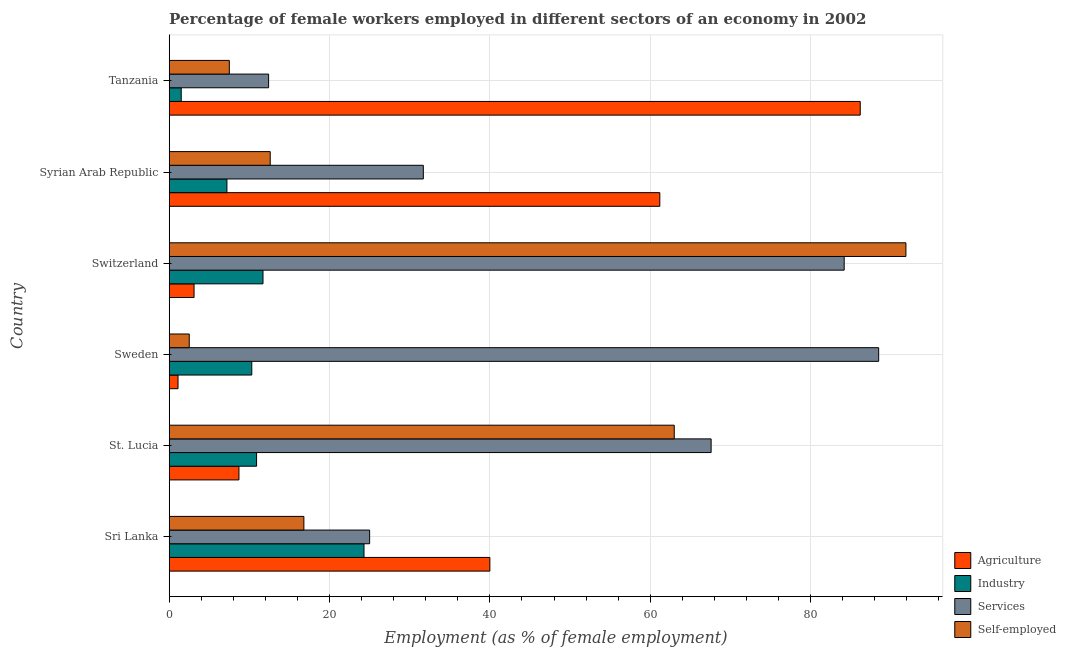How many groups of bars are there?
Ensure brevity in your answer.  6. Are the number of bars on each tick of the Y-axis equal?
Provide a short and direct response. Yes. What is the label of the 5th group of bars from the top?
Your answer should be very brief. St. Lucia. What is the percentage of female workers in agriculture in Tanzania?
Your answer should be compact. 86.2. Across all countries, what is the maximum percentage of female workers in industry?
Offer a very short reply. 24.3. In which country was the percentage of female workers in industry maximum?
Provide a short and direct response. Sri Lanka. In which country was the percentage of female workers in industry minimum?
Your response must be concise. Tanzania. What is the total percentage of female workers in agriculture in the graph?
Your answer should be compact. 200.3. What is the difference between the percentage of female workers in agriculture in Sri Lanka and that in Tanzania?
Your answer should be compact. -46.2. What is the difference between the percentage of female workers in services in Sri Lanka and the percentage of female workers in industry in Syrian Arab Republic?
Offer a very short reply. 17.8. What is the average percentage of female workers in agriculture per country?
Keep it short and to the point. 33.38. What is the difference between the percentage of female workers in services and percentage of female workers in agriculture in Switzerland?
Ensure brevity in your answer.  81.1. What is the ratio of the percentage of female workers in industry in Sri Lanka to that in Sweden?
Your response must be concise. 2.36. What is the difference between the highest and the lowest percentage of female workers in agriculture?
Your response must be concise. 85.1. Is the sum of the percentage of female workers in agriculture in Switzerland and Syrian Arab Republic greater than the maximum percentage of female workers in industry across all countries?
Your answer should be compact. Yes. What does the 1st bar from the top in St. Lucia represents?
Your answer should be very brief. Self-employed. What does the 2nd bar from the bottom in Sweden represents?
Ensure brevity in your answer.  Industry. How many countries are there in the graph?
Provide a short and direct response. 6. What is the difference between two consecutive major ticks on the X-axis?
Offer a terse response. 20. Does the graph contain any zero values?
Provide a succinct answer. No. Does the graph contain grids?
Ensure brevity in your answer.  Yes. Where does the legend appear in the graph?
Ensure brevity in your answer.  Bottom right. How many legend labels are there?
Your answer should be very brief. 4. How are the legend labels stacked?
Ensure brevity in your answer.  Vertical. What is the title of the graph?
Ensure brevity in your answer.  Percentage of female workers employed in different sectors of an economy in 2002. What is the label or title of the X-axis?
Offer a very short reply. Employment (as % of female employment). What is the label or title of the Y-axis?
Make the answer very short. Country. What is the Employment (as % of female employment) of Agriculture in Sri Lanka?
Make the answer very short. 40. What is the Employment (as % of female employment) of Industry in Sri Lanka?
Your response must be concise. 24.3. What is the Employment (as % of female employment) of Services in Sri Lanka?
Your answer should be very brief. 25. What is the Employment (as % of female employment) in Self-employed in Sri Lanka?
Offer a terse response. 16.8. What is the Employment (as % of female employment) in Agriculture in St. Lucia?
Ensure brevity in your answer.  8.7. What is the Employment (as % of female employment) of Industry in St. Lucia?
Provide a short and direct response. 10.9. What is the Employment (as % of female employment) of Services in St. Lucia?
Provide a short and direct response. 67.6. What is the Employment (as % of female employment) in Agriculture in Sweden?
Give a very brief answer. 1.1. What is the Employment (as % of female employment) in Industry in Sweden?
Your answer should be compact. 10.3. What is the Employment (as % of female employment) in Services in Sweden?
Your answer should be compact. 88.5. What is the Employment (as % of female employment) in Agriculture in Switzerland?
Your answer should be compact. 3.1. What is the Employment (as % of female employment) in Industry in Switzerland?
Provide a short and direct response. 11.7. What is the Employment (as % of female employment) in Services in Switzerland?
Offer a very short reply. 84.2. What is the Employment (as % of female employment) in Self-employed in Switzerland?
Your answer should be very brief. 91.9. What is the Employment (as % of female employment) in Agriculture in Syrian Arab Republic?
Your answer should be very brief. 61.2. What is the Employment (as % of female employment) of Industry in Syrian Arab Republic?
Keep it short and to the point. 7.2. What is the Employment (as % of female employment) in Services in Syrian Arab Republic?
Ensure brevity in your answer.  31.7. What is the Employment (as % of female employment) of Self-employed in Syrian Arab Republic?
Keep it short and to the point. 12.6. What is the Employment (as % of female employment) of Agriculture in Tanzania?
Make the answer very short. 86.2. What is the Employment (as % of female employment) of Industry in Tanzania?
Provide a short and direct response. 1.5. What is the Employment (as % of female employment) of Services in Tanzania?
Offer a very short reply. 12.4. What is the Employment (as % of female employment) in Self-employed in Tanzania?
Your answer should be compact. 7.5. Across all countries, what is the maximum Employment (as % of female employment) of Agriculture?
Give a very brief answer. 86.2. Across all countries, what is the maximum Employment (as % of female employment) of Industry?
Your answer should be compact. 24.3. Across all countries, what is the maximum Employment (as % of female employment) of Services?
Your response must be concise. 88.5. Across all countries, what is the maximum Employment (as % of female employment) in Self-employed?
Make the answer very short. 91.9. Across all countries, what is the minimum Employment (as % of female employment) in Agriculture?
Ensure brevity in your answer.  1.1. Across all countries, what is the minimum Employment (as % of female employment) of Industry?
Make the answer very short. 1.5. Across all countries, what is the minimum Employment (as % of female employment) in Services?
Offer a very short reply. 12.4. What is the total Employment (as % of female employment) in Agriculture in the graph?
Provide a short and direct response. 200.3. What is the total Employment (as % of female employment) in Industry in the graph?
Your answer should be very brief. 65.9. What is the total Employment (as % of female employment) in Services in the graph?
Your response must be concise. 309.4. What is the total Employment (as % of female employment) of Self-employed in the graph?
Provide a short and direct response. 194.3. What is the difference between the Employment (as % of female employment) in Agriculture in Sri Lanka and that in St. Lucia?
Provide a succinct answer. 31.3. What is the difference between the Employment (as % of female employment) in Services in Sri Lanka and that in St. Lucia?
Keep it short and to the point. -42.6. What is the difference between the Employment (as % of female employment) in Self-employed in Sri Lanka and that in St. Lucia?
Your response must be concise. -46.2. What is the difference between the Employment (as % of female employment) in Agriculture in Sri Lanka and that in Sweden?
Offer a very short reply. 38.9. What is the difference between the Employment (as % of female employment) in Industry in Sri Lanka and that in Sweden?
Give a very brief answer. 14. What is the difference between the Employment (as % of female employment) of Services in Sri Lanka and that in Sweden?
Your response must be concise. -63.5. What is the difference between the Employment (as % of female employment) in Agriculture in Sri Lanka and that in Switzerland?
Your answer should be very brief. 36.9. What is the difference between the Employment (as % of female employment) in Industry in Sri Lanka and that in Switzerland?
Make the answer very short. 12.6. What is the difference between the Employment (as % of female employment) of Services in Sri Lanka and that in Switzerland?
Make the answer very short. -59.2. What is the difference between the Employment (as % of female employment) in Self-employed in Sri Lanka and that in Switzerland?
Your answer should be very brief. -75.1. What is the difference between the Employment (as % of female employment) in Agriculture in Sri Lanka and that in Syrian Arab Republic?
Your response must be concise. -21.2. What is the difference between the Employment (as % of female employment) of Industry in Sri Lanka and that in Syrian Arab Republic?
Your answer should be compact. 17.1. What is the difference between the Employment (as % of female employment) in Self-employed in Sri Lanka and that in Syrian Arab Republic?
Ensure brevity in your answer.  4.2. What is the difference between the Employment (as % of female employment) of Agriculture in Sri Lanka and that in Tanzania?
Provide a succinct answer. -46.2. What is the difference between the Employment (as % of female employment) of Industry in Sri Lanka and that in Tanzania?
Offer a very short reply. 22.8. What is the difference between the Employment (as % of female employment) of Services in St. Lucia and that in Sweden?
Make the answer very short. -20.9. What is the difference between the Employment (as % of female employment) in Self-employed in St. Lucia and that in Sweden?
Your response must be concise. 60.5. What is the difference between the Employment (as % of female employment) in Agriculture in St. Lucia and that in Switzerland?
Offer a very short reply. 5.6. What is the difference between the Employment (as % of female employment) in Industry in St. Lucia and that in Switzerland?
Your response must be concise. -0.8. What is the difference between the Employment (as % of female employment) of Services in St. Lucia and that in Switzerland?
Make the answer very short. -16.6. What is the difference between the Employment (as % of female employment) in Self-employed in St. Lucia and that in Switzerland?
Offer a terse response. -28.9. What is the difference between the Employment (as % of female employment) in Agriculture in St. Lucia and that in Syrian Arab Republic?
Your answer should be compact. -52.5. What is the difference between the Employment (as % of female employment) of Services in St. Lucia and that in Syrian Arab Republic?
Keep it short and to the point. 35.9. What is the difference between the Employment (as % of female employment) of Self-employed in St. Lucia and that in Syrian Arab Republic?
Ensure brevity in your answer.  50.4. What is the difference between the Employment (as % of female employment) of Agriculture in St. Lucia and that in Tanzania?
Your answer should be compact. -77.5. What is the difference between the Employment (as % of female employment) in Services in St. Lucia and that in Tanzania?
Keep it short and to the point. 55.2. What is the difference between the Employment (as % of female employment) of Self-employed in St. Lucia and that in Tanzania?
Your response must be concise. 55.5. What is the difference between the Employment (as % of female employment) of Self-employed in Sweden and that in Switzerland?
Your response must be concise. -89.4. What is the difference between the Employment (as % of female employment) in Agriculture in Sweden and that in Syrian Arab Republic?
Offer a terse response. -60.1. What is the difference between the Employment (as % of female employment) of Services in Sweden and that in Syrian Arab Republic?
Provide a short and direct response. 56.8. What is the difference between the Employment (as % of female employment) of Self-employed in Sweden and that in Syrian Arab Republic?
Offer a terse response. -10.1. What is the difference between the Employment (as % of female employment) in Agriculture in Sweden and that in Tanzania?
Make the answer very short. -85.1. What is the difference between the Employment (as % of female employment) in Industry in Sweden and that in Tanzania?
Offer a terse response. 8.8. What is the difference between the Employment (as % of female employment) in Services in Sweden and that in Tanzania?
Give a very brief answer. 76.1. What is the difference between the Employment (as % of female employment) of Agriculture in Switzerland and that in Syrian Arab Republic?
Your response must be concise. -58.1. What is the difference between the Employment (as % of female employment) of Industry in Switzerland and that in Syrian Arab Republic?
Your answer should be very brief. 4.5. What is the difference between the Employment (as % of female employment) in Services in Switzerland and that in Syrian Arab Republic?
Keep it short and to the point. 52.5. What is the difference between the Employment (as % of female employment) in Self-employed in Switzerland and that in Syrian Arab Republic?
Keep it short and to the point. 79.3. What is the difference between the Employment (as % of female employment) in Agriculture in Switzerland and that in Tanzania?
Provide a succinct answer. -83.1. What is the difference between the Employment (as % of female employment) in Industry in Switzerland and that in Tanzania?
Provide a succinct answer. 10.2. What is the difference between the Employment (as % of female employment) of Services in Switzerland and that in Tanzania?
Offer a terse response. 71.8. What is the difference between the Employment (as % of female employment) of Self-employed in Switzerland and that in Tanzania?
Keep it short and to the point. 84.4. What is the difference between the Employment (as % of female employment) of Services in Syrian Arab Republic and that in Tanzania?
Provide a succinct answer. 19.3. What is the difference between the Employment (as % of female employment) of Self-employed in Syrian Arab Republic and that in Tanzania?
Offer a very short reply. 5.1. What is the difference between the Employment (as % of female employment) in Agriculture in Sri Lanka and the Employment (as % of female employment) in Industry in St. Lucia?
Give a very brief answer. 29.1. What is the difference between the Employment (as % of female employment) of Agriculture in Sri Lanka and the Employment (as % of female employment) of Services in St. Lucia?
Make the answer very short. -27.6. What is the difference between the Employment (as % of female employment) of Industry in Sri Lanka and the Employment (as % of female employment) of Services in St. Lucia?
Your answer should be very brief. -43.3. What is the difference between the Employment (as % of female employment) of Industry in Sri Lanka and the Employment (as % of female employment) of Self-employed in St. Lucia?
Provide a short and direct response. -38.7. What is the difference between the Employment (as % of female employment) of Services in Sri Lanka and the Employment (as % of female employment) of Self-employed in St. Lucia?
Your answer should be compact. -38. What is the difference between the Employment (as % of female employment) of Agriculture in Sri Lanka and the Employment (as % of female employment) of Industry in Sweden?
Your answer should be compact. 29.7. What is the difference between the Employment (as % of female employment) in Agriculture in Sri Lanka and the Employment (as % of female employment) in Services in Sweden?
Provide a short and direct response. -48.5. What is the difference between the Employment (as % of female employment) in Agriculture in Sri Lanka and the Employment (as % of female employment) in Self-employed in Sweden?
Ensure brevity in your answer.  37.5. What is the difference between the Employment (as % of female employment) of Industry in Sri Lanka and the Employment (as % of female employment) of Services in Sweden?
Your answer should be very brief. -64.2. What is the difference between the Employment (as % of female employment) of Industry in Sri Lanka and the Employment (as % of female employment) of Self-employed in Sweden?
Your response must be concise. 21.8. What is the difference between the Employment (as % of female employment) in Agriculture in Sri Lanka and the Employment (as % of female employment) in Industry in Switzerland?
Provide a short and direct response. 28.3. What is the difference between the Employment (as % of female employment) of Agriculture in Sri Lanka and the Employment (as % of female employment) of Services in Switzerland?
Your answer should be compact. -44.2. What is the difference between the Employment (as % of female employment) of Agriculture in Sri Lanka and the Employment (as % of female employment) of Self-employed in Switzerland?
Provide a short and direct response. -51.9. What is the difference between the Employment (as % of female employment) of Industry in Sri Lanka and the Employment (as % of female employment) of Services in Switzerland?
Your answer should be very brief. -59.9. What is the difference between the Employment (as % of female employment) in Industry in Sri Lanka and the Employment (as % of female employment) in Self-employed in Switzerland?
Offer a very short reply. -67.6. What is the difference between the Employment (as % of female employment) in Services in Sri Lanka and the Employment (as % of female employment) in Self-employed in Switzerland?
Offer a very short reply. -66.9. What is the difference between the Employment (as % of female employment) of Agriculture in Sri Lanka and the Employment (as % of female employment) of Industry in Syrian Arab Republic?
Offer a terse response. 32.8. What is the difference between the Employment (as % of female employment) in Agriculture in Sri Lanka and the Employment (as % of female employment) in Services in Syrian Arab Republic?
Ensure brevity in your answer.  8.3. What is the difference between the Employment (as % of female employment) of Agriculture in Sri Lanka and the Employment (as % of female employment) of Self-employed in Syrian Arab Republic?
Your answer should be very brief. 27.4. What is the difference between the Employment (as % of female employment) of Industry in Sri Lanka and the Employment (as % of female employment) of Services in Syrian Arab Republic?
Keep it short and to the point. -7.4. What is the difference between the Employment (as % of female employment) of Services in Sri Lanka and the Employment (as % of female employment) of Self-employed in Syrian Arab Republic?
Give a very brief answer. 12.4. What is the difference between the Employment (as % of female employment) of Agriculture in Sri Lanka and the Employment (as % of female employment) of Industry in Tanzania?
Make the answer very short. 38.5. What is the difference between the Employment (as % of female employment) in Agriculture in Sri Lanka and the Employment (as % of female employment) in Services in Tanzania?
Ensure brevity in your answer.  27.6. What is the difference between the Employment (as % of female employment) of Agriculture in Sri Lanka and the Employment (as % of female employment) of Self-employed in Tanzania?
Make the answer very short. 32.5. What is the difference between the Employment (as % of female employment) in Industry in Sri Lanka and the Employment (as % of female employment) in Self-employed in Tanzania?
Give a very brief answer. 16.8. What is the difference between the Employment (as % of female employment) of Agriculture in St. Lucia and the Employment (as % of female employment) of Services in Sweden?
Your answer should be very brief. -79.8. What is the difference between the Employment (as % of female employment) in Agriculture in St. Lucia and the Employment (as % of female employment) in Self-employed in Sweden?
Keep it short and to the point. 6.2. What is the difference between the Employment (as % of female employment) of Industry in St. Lucia and the Employment (as % of female employment) of Services in Sweden?
Make the answer very short. -77.6. What is the difference between the Employment (as % of female employment) in Services in St. Lucia and the Employment (as % of female employment) in Self-employed in Sweden?
Ensure brevity in your answer.  65.1. What is the difference between the Employment (as % of female employment) of Agriculture in St. Lucia and the Employment (as % of female employment) of Industry in Switzerland?
Provide a short and direct response. -3. What is the difference between the Employment (as % of female employment) in Agriculture in St. Lucia and the Employment (as % of female employment) in Services in Switzerland?
Your answer should be compact. -75.5. What is the difference between the Employment (as % of female employment) in Agriculture in St. Lucia and the Employment (as % of female employment) in Self-employed in Switzerland?
Provide a short and direct response. -83.2. What is the difference between the Employment (as % of female employment) in Industry in St. Lucia and the Employment (as % of female employment) in Services in Switzerland?
Keep it short and to the point. -73.3. What is the difference between the Employment (as % of female employment) of Industry in St. Lucia and the Employment (as % of female employment) of Self-employed in Switzerland?
Make the answer very short. -81. What is the difference between the Employment (as % of female employment) in Services in St. Lucia and the Employment (as % of female employment) in Self-employed in Switzerland?
Offer a terse response. -24.3. What is the difference between the Employment (as % of female employment) of Agriculture in St. Lucia and the Employment (as % of female employment) of Services in Syrian Arab Republic?
Offer a very short reply. -23. What is the difference between the Employment (as % of female employment) in Industry in St. Lucia and the Employment (as % of female employment) in Services in Syrian Arab Republic?
Provide a short and direct response. -20.8. What is the difference between the Employment (as % of female employment) in Industry in St. Lucia and the Employment (as % of female employment) in Self-employed in Syrian Arab Republic?
Your answer should be compact. -1.7. What is the difference between the Employment (as % of female employment) in Services in St. Lucia and the Employment (as % of female employment) in Self-employed in Syrian Arab Republic?
Keep it short and to the point. 55. What is the difference between the Employment (as % of female employment) in Agriculture in St. Lucia and the Employment (as % of female employment) in Industry in Tanzania?
Your answer should be compact. 7.2. What is the difference between the Employment (as % of female employment) of Agriculture in St. Lucia and the Employment (as % of female employment) of Self-employed in Tanzania?
Make the answer very short. 1.2. What is the difference between the Employment (as % of female employment) in Industry in St. Lucia and the Employment (as % of female employment) in Services in Tanzania?
Ensure brevity in your answer.  -1.5. What is the difference between the Employment (as % of female employment) of Services in St. Lucia and the Employment (as % of female employment) of Self-employed in Tanzania?
Ensure brevity in your answer.  60.1. What is the difference between the Employment (as % of female employment) of Agriculture in Sweden and the Employment (as % of female employment) of Services in Switzerland?
Your answer should be very brief. -83.1. What is the difference between the Employment (as % of female employment) in Agriculture in Sweden and the Employment (as % of female employment) in Self-employed in Switzerland?
Offer a very short reply. -90.8. What is the difference between the Employment (as % of female employment) of Industry in Sweden and the Employment (as % of female employment) of Services in Switzerland?
Keep it short and to the point. -73.9. What is the difference between the Employment (as % of female employment) in Industry in Sweden and the Employment (as % of female employment) in Self-employed in Switzerland?
Provide a succinct answer. -81.6. What is the difference between the Employment (as % of female employment) in Agriculture in Sweden and the Employment (as % of female employment) in Services in Syrian Arab Republic?
Offer a very short reply. -30.6. What is the difference between the Employment (as % of female employment) of Agriculture in Sweden and the Employment (as % of female employment) of Self-employed in Syrian Arab Republic?
Give a very brief answer. -11.5. What is the difference between the Employment (as % of female employment) in Industry in Sweden and the Employment (as % of female employment) in Services in Syrian Arab Republic?
Provide a succinct answer. -21.4. What is the difference between the Employment (as % of female employment) in Services in Sweden and the Employment (as % of female employment) in Self-employed in Syrian Arab Republic?
Keep it short and to the point. 75.9. What is the difference between the Employment (as % of female employment) of Agriculture in Sweden and the Employment (as % of female employment) of Self-employed in Tanzania?
Offer a very short reply. -6.4. What is the difference between the Employment (as % of female employment) in Industry in Sweden and the Employment (as % of female employment) in Self-employed in Tanzania?
Provide a succinct answer. 2.8. What is the difference between the Employment (as % of female employment) of Services in Sweden and the Employment (as % of female employment) of Self-employed in Tanzania?
Offer a terse response. 81. What is the difference between the Employment (as % of female employment) of Agriculture in Switzerland and the Employment (as % of female employment) of Services in Syrian Arab Republic?
Keep it short and to the point. -28.6. What is the difference between the Employment (as % of female employment) in Agriculture in Switzerland and the Employment (as % of female employment) in Self-employed in Syrian Arab Republic?
Ensure brevity in your answer.  -9.5. What is the difference between the Employment (as % of female employment) of Industry in Switzerland and the Employment (as % of female employment) of Self-employed in Syrian Arab Republic?
Ensure brevity in your answer.  -0.9. What is the difference between the Employment (as % of female employment) of Services in Switzerland and the Employment (as % of female employment) of Self-employed in Syrian Arab Republic?
Provide a short and direct response. 71.6. What is the difference between the Employment (as % of female employment) of Agriculture in Switzerland and the Employment (as % of female employment) of Industry in Tanzania?
Provide a short and direct response. 1.6. What is the difference between the Employment (as % of female employment) of Agriculture in Switzerland and the Employment (as % of female employment) of Services in Tanzania?
Ensure brevity in your answer.  -9.3. What is the difference between the Employment (as % of female employment) of Agriculture in Switzerland and the Employment (as % of female employment) of Self-employed in Tanzania?
Ensure brevity in your answer.  -4.4. What is the difference between the Employment (as % of female employment) of Industry in Switzerland and the Employment (as % of female employment) of Services in Tanzania?
Ensure brevity in your answer.  -0.7. What is the difference between the Employment (as % of female employment) in Services in Switzerland and the Employment (as % of female employment) in Self-employed in Tanzania?
Make the answer very short. 76.7. What is the difference between the Employment (as % of female employment) of Agriculture in Syrian Arab Republic and the Employment (as % of female employment) of Industry in Tanzania?
Make the answer very short. 59.7. What is the difference between the Employment (as % of female employment) in Agriculture in Syrian Arab Republic and the Employment (as % of female employment) in Services in Tanzania?
Provide a succinct answer. 48.8. What is the difference between the Employment (as % of female employment) of Agriculture in Syrian Arab Republic and the Employment (as % of female employment) of Self-employed in Tanzania?
Provide a succinct answer. 53.7. What is the difference between the Employment (as % of female employment) in Services in Syrian Arab Republic and the Employment (as % of female employment) in Self-employed in Tanzania?
Your answer should be compact. 24.2. What is the average Employment (as % of female employment) in Agriculture per country?
Offer a terse response. 33.38. What is the average Employment (as % of female employment) in Industry per country?
Give a very brief answer. 10.98. What is the average Employment (as % of female employment) in Services per country?
Your answer should be very brief. 51.57. What is the average Employment (as % of female employment) of Self-employed per country?
Your answer should be very brief. 32.38. What is the difference between the Employment (as % of female employment) of Agriculture and Employment (as % of female employment) of Self-employed in Sri Lanka?
Offer a terse response. 23.2. What is the difference between the Employment (as % of female employment) of Industry and Employment (as % of female employment) of Services in Sri Lanka?
Your answer should be very brief. -0.7. What is the difference between the Employment (as % of female employment) of Agriculture and Employment (as % of female employment) of Industry in St. Lucia?
Your answer should be very brief. -2.2. What is the difference between the Employment (as % of female employment) of Agriculture and Employment (as % of female employment) of Services in St. Lucia?
Offer a very short reply. -58.9. What is the difference between the Employment (as % of female employment) in Agriculture and Employment (as % of female employment) in Self-employed in St. Lucia?
Your answer should be compact. -54.3. What is the difference between the Employment (as % of female employment) of Industry and Employment (as % of female employment) of Services in St. Lucia?
Your answer should be very brief. -56.7. What is the difference between the Employment (as % of female employment) of Industry and Employment (as % of female employment) of Self-employed in St. Lucia?
Offer a terse response. -52.1. What is the difference between the Employment (as % of female employment) of Agriculture and Employment (as % of female employment) of Industry in Sweden?
Offer a very short reply. -9.2. What is the difference between the Employment (as % of female employment) of Agriculture and Employment (as % of female employment) of Services in Sweden?
Your response must be concise. -87.4. What is the difference between the Employment (as % of female employment) of Industry and Employment (as % of female employment) of Services in Sweden?
Provide a succinct answer. -78.2. What is the difference between the Employment (as % of female employment) in Services and Employment (as % of female employment) in Self-employed in Sweden?
Make the answer very short. 86. What is the difference between the Employment (as % of female employment) in Agriculture and Employment (as % of female employment) in Services in Switzerland?
Provide a short and direct response. -81.1. What is the difference between the Employment (as % of female employment) in Agriculture and Employment (as % of female employment) in Self-employed in Switzerland?
Your answer should be very brief. -88.8. What is the difference between the Employment (as % of female employment) of Industry and Employment (as % of female employment) of Services in Switzerland?
Your response must be concise. -72.5. What is the difference between the Employment (as % of female employment) of Industry and Employment (as % of female employment) of Self-employed in Switzerland?
Your answer should be very brief. -80.2. What is the difference between the Employment (as % of female employment) of Agriculture and Employment (as % of female employment) of Services in Syrian Arab Republic?
Give a very brief answer. 29.5. What is the difference between the Employment (as % of female employment) in Agriculture and Employment (as % of female employment) in Self-employed in Syrian Arab Republic?
Provide a succinct answer. 48.6. What is the difference between the Employment (as % of female employment) in Industry and Employment (as % of female employment) in Services in Syrian Arab Republic?
Offer a very short reply. -24.5. What is the difference between the Employment (as % of female employment) of Industry and Employment (as % of female employment) of Self-employed in Syrian Arab Republic?
Offer a terse response. -5.4. What is the difference between the Employment (as % of female employment) in Agriculture and Employment (as % of female employment) in Industry in Tanzania?
Provide a succinct answer. 84.7. What is the difference between the Employment (as % of female employment) of Agriculture and Employment (as % of female employment) of Services in Tanzania?
Give a very brief answer. 73.8. What is the difference between the Employment (as % of female employment) of Agriculture and Employment (as % of female employment) of Self-employed in Tanzania?
Offer a terse response. 78.7. What is the difference between the Employment (as % of female employment) in Industry and Employment (as % of female employment) in Services in Tanzania?
Your answer should be very brief. -10.9. What is the difference between the Employment (as % of female employment) of Services and Employment (as % of female employment) of Self-employed in Tanzania?
Keep it short and to the point. 4.9. What is the ratio of the Employment (as % of female employment) of Agriculture in Sri Lanka to that in St. Lucia?
Your answer should be compact. 4.6. What is the ratio of the Employment (as % of female employment) in Industry in Sri Lanka to that in St. Lucia?
Keep it short and to the point. 2.23. What is the ratio of the Employment (as % of female employment) in Services in Sri Lanka to that in St. Lucia?
Provide a short and direct response. 0.37. What is the ratio of the Employment (as % of female employment) in Self-employed in Sri Lanka to that in St. Lucia?
Make the answer very short. 0.27. What is the ratio of the Employment (as % of female employment) in Agriculture in Sri Lanka to that in Sweden?
Provide a short and direct response. 36.36. What is the ratio of the Employment (as % of female employment) in Industry in Sri Lanka to that in Sweden?
Make the answer very short. 2.36. What is the ratio of the Employment (as % of female employment) in Services in Sri Lanka to that in Sweden?
Your answer should be compact. 0.28. What is the ratio of the Employment (as % of female employment) of Self-employed in Sri Lanka to that in Sweden?
Give a very brief answer. 6.72. What is the ratio of the Employment (as % of female employment) of Agriculture in Sri Lanka to that in Switzerland?
Your answer should be compact. 12.9. What is the ratio of the Employment (as % of female employment) of Industry in Sri Lanka to that in Switzerland?
Provide a short and direct response. 2.08. What is the ratio of the Employment (as % of female employment) in Services in Sri Lanka to that in Switzerland?
Provide a succinct answer. 0.3. What is the ratio of the Employment (as % of female employment) of Self-employed in Sri Lanka to that in Switzerland?
Your answer should be compact. 0.18. What is the ratio of the Employment (as % of female employment) in Agriculture in Sri Lanka to that in Syrian Arab Republic?
Your answer should be very brief. 0.65. What is the ratio of the Employment (as % of female employment) of Industry in Sri Lanka to that in Syrian Arab Republic?
Offer a very short reply. 3.38. What is the ratio of the Employment (as % of female employment) in Services in Sri Lanka to that in Syrian Arab Republic?
Keep it short and to the point. 0.79. What is the ratio of the Employment (as % of female employment) of Agriculture in Sri Lanka to that in Tanzania?
Your answer should be very brief. 0.46. What is the ratio of the Employment (as % of female employment) in Industry in Sri Lanka to that in Tanzania?
Your response must be concise. 16.2. What is the ratio of the Employment (as % of female employment) of Services in Sri Lanka to that in Tanzania?
Ensure brevity in your answer.  2.02. What is the ratio of the Employment (as % of female employment) of Self-employed in Sri Lanka to that in Tanzania?
Keep it short and to the point. 2.24. What is the ratio of the Employment (as % of female employment) in Agriculture in St. Lucia to that in Sweden?
Give a very brief answer. 7.91. What is the ratio of the Employment (as % of female employment) in Industry in St. Lucia to that in Sweden?
Your answer should be compact. 1.06. What is the ratio of the Employment (as % of female employment) of Services in St. Lucia to that in Sweden?
Provide a succinct answer. 0.76. What is the ratio of the Employment (as % of female employment) of Self-employed in St. Lucia to that in Sweden?
Provide a succinct answer. 25.2. What is the ratio of the Employment (as % of female employment) in Agriculture in St. Lucia to that in Switzerland?
Your response must be concise. 2.81. What is the ratio of the Employment (as % of female employment) in Industry in St. Lucia to that in Switzerland?
Offer a very short reply. 0.93. What is the ratio of the Employment (as % of female employment) of Services in St. Lucia to that in Switzerland?
Provide a short and direct response. 0.8. What is the ratio of the Employment (as % of female employment) of Self-employed in St. Lucia to that in Switzerland?
Give a very brief answer. 0.69. What is the ratio of the Employment (as % of female employment) in Agriculture in St. Lucia to that in Syrian Arab Republic?
Give a very brief answer. 0.14. What is the ratio of the Employment (as % of female employment) of Industry in St. Lucia to that in Syrian Arab Republic?
Make the answer very short. 1.51. What is the ratio of the Employment (as % of female employment) in Services in St. Lucia to that in Syrian Arab Republic?
Your answer should be compact. 2.13. What is the ratio of the Employment (as % of female employment) of Agriculture in St. Lucia to that in Tanzania?
Offer a very short reply. 0.1. What is the ratio of the Employment (as % of female employment) in Industry in St. Lucia to that in Tanzania?
Give a very brief answer. 7.27. What is the ratio of the Employment (as % of female employment) of Services in St. Lucia to that in Tanzania?
Your answer should be very brief. 5.45. What is the ratio of the Employment (as % of female employment) of Agriculture in Sweden to that in Switzerland?
Keep it short and to the point. 0.35. What is the ratio of the Employment (as % of female employment) in Industry in Sweden to that in Switzerland?
Give a very brief answer. 0.88. What is the ratio of the Employment (as % of female employment) of Services in Sweden to that in Switzerland?
Offer a very short reply. 1.05. What is the ratio of the Employment (as % of female employment) in Self-employed in Sweden to that in Switzerland?
Give a very brief answer. 0.03. What is the ratio of the Employment (as % of female employment) of Agriculture in Sweden to that in Syrian Arab Republic?
Offer a very short reply. 0.02. What is the ratio of the Employment (as % of female employment) in Industry in Sweden to that in Syrian Arab Republic?
Keep it short and to the point. 1.43. What is the ratio of the Employment (as % of female employment) in Services in Sweden to that in Syrian Arab Republic?
Keep it short and to the point. 2.79. What is the ratio of the Employment (as % of female employment) of Self-employed in Sweden to that in Syrian Arab Republic?
Ensure brevity in your answer.  0.2. What is the ratio of the Employment (as % of female employment) of Agriculture in Sweden to that in Tanzania?
Keep it short and to the point. 0.01. What is the ratio of the Employment (as % of female employment) of Industry in Sweden to that in Tanzania?
Keep it short and to the point. 6.87. What is the ratio of the Employment (as % of female employment) of Services in Sweden to that in Tanzania?
Make the answer very short. 7.14. What is the ratio of the Employment (as % of female employment) in Agriculture in Switzerland to that in Syrian Arab Republic?
Your answer should be compact. 0.05. What is the ratio of the Employment (as % of female employment) of Industry in Switzerland to that in Syrian Arab Republic?
Keep it short and to the point. 1.62. What is the ratio of the Employment (as % of female employment) in Services in Switzerland to that in Syrian Arab Republic?
Keep it short and to the point. 2.66. What is the ratio of the Employment (as % of female employment) of Self-employed in Switzerland to that in Syrian Arab Republic?
Keep it short and to the point. 7.29. What is the ratio of the Employment (as % of female employment) in Agriculture in Switzerland to that in Tanzania?
Provide a short and direct response. 0.04. What is the ratio of the Employment (as % of female employment) of Industry in Switzerland to that in Tanzania?
Ensure brevity in your answer.  7.8. What is the ratio of the Employment (as % of female employment) in Services in Switzerland to that in Tanzania?
Offer a very short reply. 6.79. What is the ratio of the Employment (as % of female employment) of Self-employed in Switzerland to that in Tanzania?
Your answer should be very brief. 12.25. What is the ratio of the Employment (as % of female employment) of Agriculture in Syrian Arab Republic to that in Tanzania?
Ensure brevity in your answer.  0.71. What is the ratio of the Employment (as % of female employment) of Industry in Syrian Arab Republic to that in Tanzania?
Provide a succinct answer. 4.8. What is the ratio of the Employment (as % of female employment) in Services in Syrian Arab Republic to that in Tanzania?
Provide a succinct answer. 2.56. What is the ratio of the Employment (as % of female employment) of Self-employed in Syrian Arab Republic to that in Tanzania?
Offer a very short reply. 1.68. What is the difference between the highest and the second highest Employment (as % of female employment) in Industry?
Keep it short and to the point. 12.6. What is the difference between the highest and the second highest Employment (as % of female employment) in Services?
Your answer should be compact. 4.3. What is the difference between the highest and the second highest Employment (as % of female employment) in Self-employed?
Give a very brief answer. 28.9. What is the difference between the highest and the lowest Employment (as % of female employment) of Agriculture?
Provide a succinct answer. 85.1. What is the difference between the highest and the lowest Employment (as % of female employment) in Industry?
Make the answer very short. 22.8. What is the difference between the highest and the lowest Employment (as % of female employment) in Services?
Keep it short and to the point. 76.1. What is the difference between the highest and the lowest Employment (as % of female employment) of Self-employed?
Your answer should be compact. 89.4. 